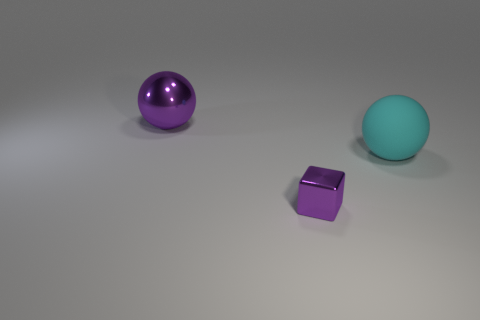Does the cube have the same color as the large metal thing?
Ensure brevity in your answer.  Yes. What number of objects are large spheres that are on the left side of the purple block or cyan matte things?
Your response must be concise. 2. There is a thing that is in front of the sphere in front of the large purple metal thing left of the purple block; what color is it?
Provide a short and direct response. Purple. What color is the sphere that is made of the same material as the small purple thing?
Give a very brief answer. Purple. How many large purple balls are made of the same material as the small block?
Your response must be concise. 1. There is a purple thing that is behind the cyan matte thing; does it have the same size as the purple metal cube?
Offer a terse response. No. What is the color of the other ball that is the same size as the purple ball?
Provide a short and direct response. Cyan. How many tiny purple shiny objects are behind the big cyan thing?
Ensure brevity in your answer.  0. Is there a big purple matte ball?
Keep it short and to the point. No. There is a shiny object behind the large object right of the purple object on the left side of the block; what size is it?
Make the answer very short. Large. 